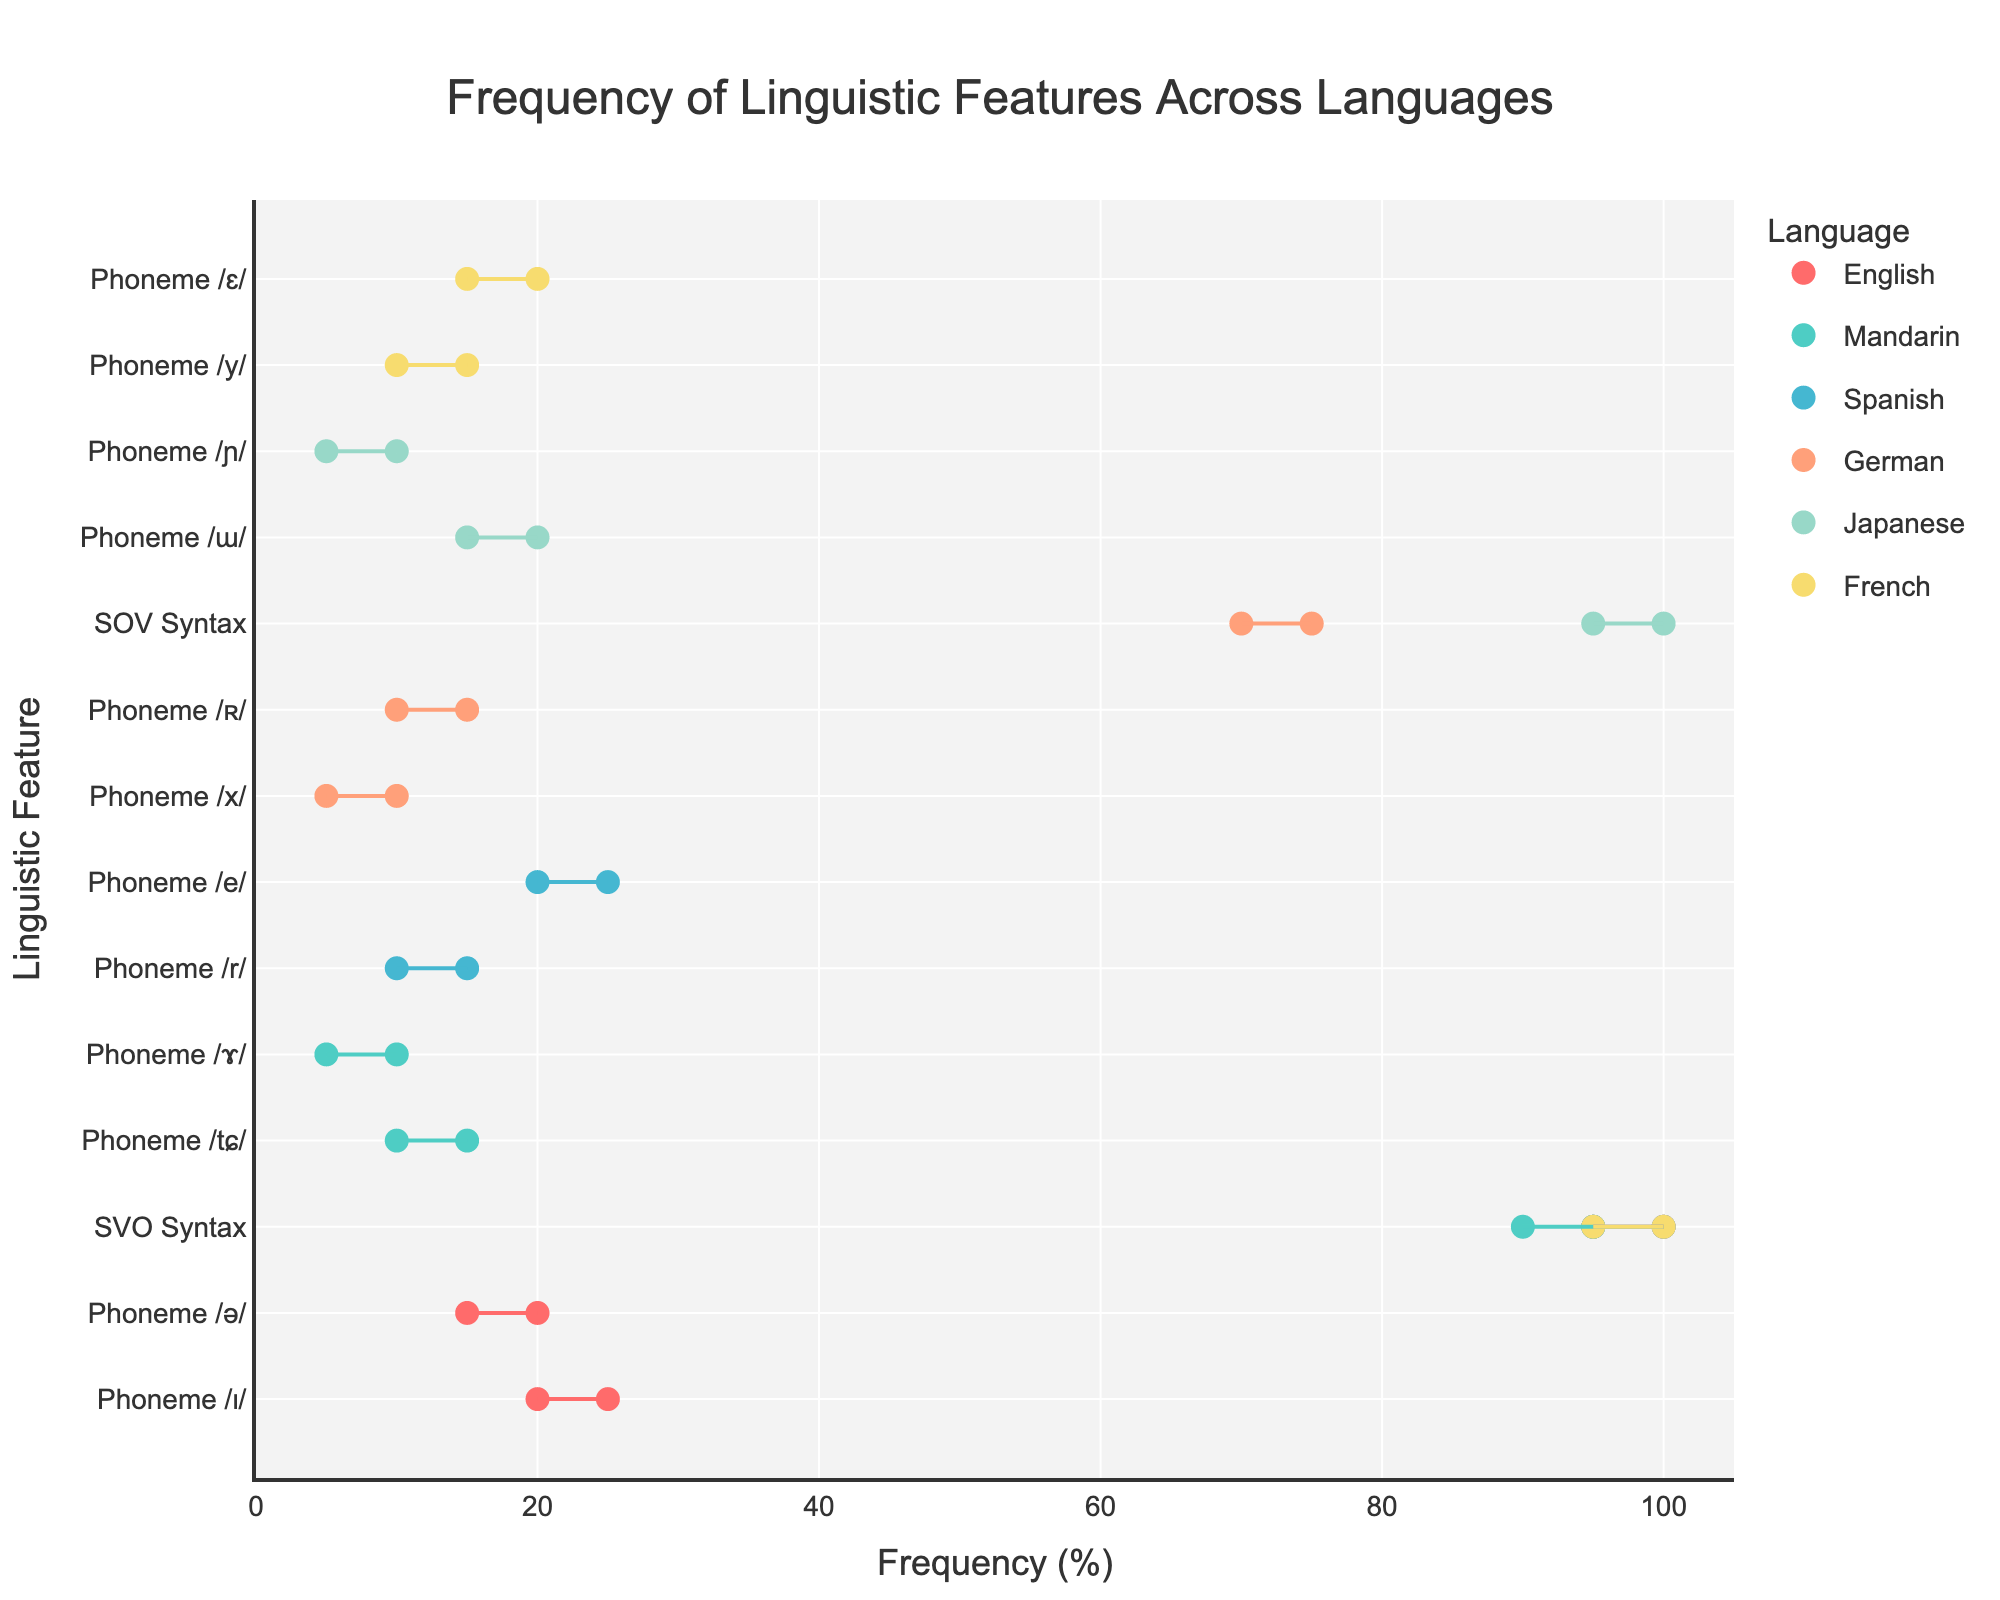what is the title of the plot? The title is located at the top of the plot. It is "Frequency of Linguistic Features Across Languages".
Answer: Frequency of Linguistic Features Across Languages How many languages are represented in the plot? The unique languages can be identified from different colors and legends. There are 6 languages: English, Mandarin, Spanish, German, Japanese, and French.
Answer: 6 What is the frequency range of the Phoneme /ɯ/ in Japanese? We look for the y-axis point that corresponds to "Phoneme /ɯ/" under Japanese. The x-axis markers at this point indicate the range is between 15% and 20%.
Answer: 15-20% Among the phonemes listed for English, which has the highest frequency range? By checking the English phonemes, we compare their frequency ranges. Phoneme /ɪ/ has a range of 20-25% which is the highest.
Answer: Phoneme /ɪ/ Which language has the second highest maximum frequency for SVO Syntax? We identify the languages with SVO Syntax and compare their maximum values. The highest is English (100%), followed by Mandarin (95%).
Answer: Mandarin How does the frequency range of SOV Syntax in Japanese compare with SOV Syntax in German? We find Japanese SOV Syntax frequency range (95-100%) and German SOV Syntax range (70-75%). Japanese has a higher frequency range.
Answer: Japanese is higher Which language has the broadest range for any listed linguistic feature? We compare all frequency ranges' widths (Max-Min). English's SVO Syntax has 5 units (95-100%), which is the broadest.
Answer: English SVO Syntax What is the combined frequency range for both phonemes listed in Mandarin? Mandarin has phonemes /tɕ/ (10-15%) and /ɤ/ (5-10%). We add both ranges together: (10+15=25%) and (5+10=15%).
Answer: 15-25% What is the average minimum frequency for the phonemes listed in Spanish? Spanish phonemes: /r/ (10-15%), /e/ (20-25%). The minimal frequencies are 10% and 20%. The average is (10+20)/2 = 15%.
Answer: 15% 